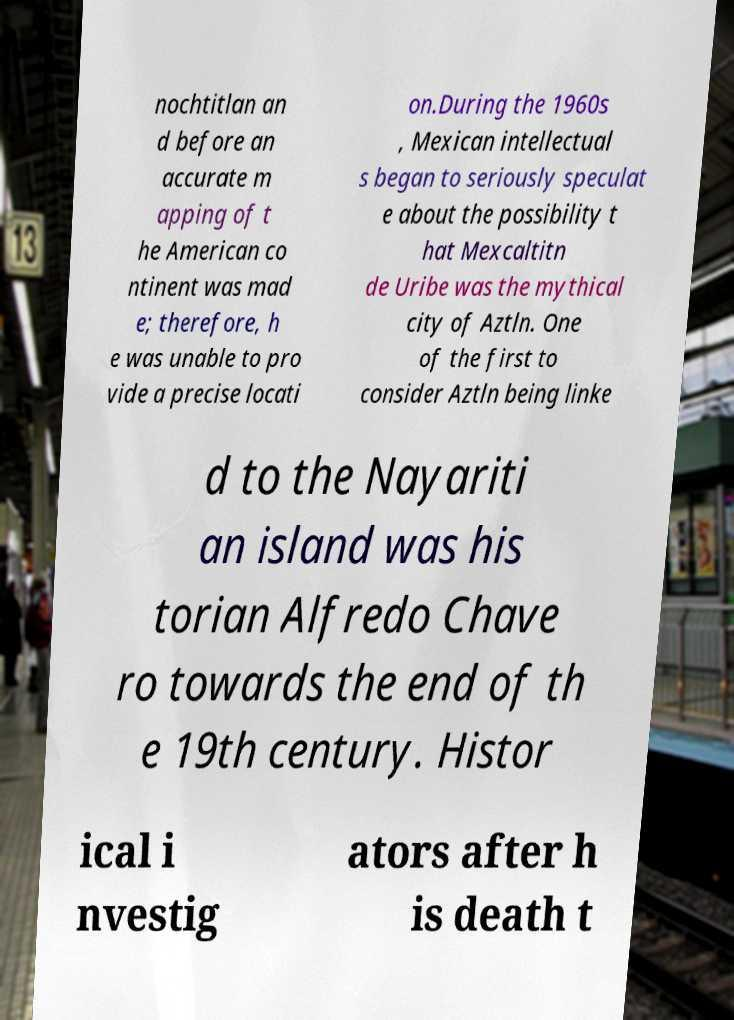Can you accurately transcribe the text from the provided image for me? nochtitlan an d before an accurate m apping of t he American co ntinent was mad e; therefore, h e was unable to pro vide a precise locati on.During the 1960s , Mexican intellectual s began to seriously speculat e about the possibility t hat Mexcaltitn de Uribe was the mythical city of Aztln. One of the first to consider Aztln being linke d to the Nayariti an island was his torian Alfredo Chave ro towards the end of th e 19th century. Histor ical i nvestig ators after h is death t 